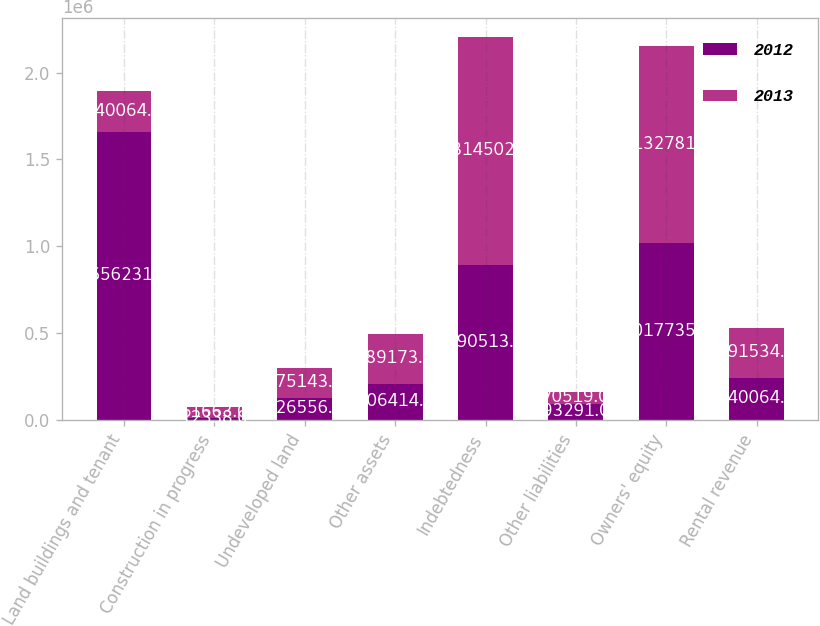Convert chart. <chart><loc_0><loc_0><loc_500><loc_500><stacked_bar_chart><ecel><fcel>Land buildings and tenant<fcel>Construction in progress<fcel>Undeveloped land<fcel>Other assets<fcel>Indebtedness<fcel>Other liabilities<fcel>Owners' equity<fcel>Rental revenue<nl><fcel>2012<fcel>1.65623e+06<fcel>12338<fcel>126556<fcel>206414<fcel>890513<fcel>93291<fcel>1.01774e+06<fcel>240064<nl><fcel>2013<fcel>240064<fcel>61663<fcel>175143<fcel>289173<fcel>1.3145e+06<fcel>70519<fcel>1.13278e+06<fcel>291534<nl></chart> 